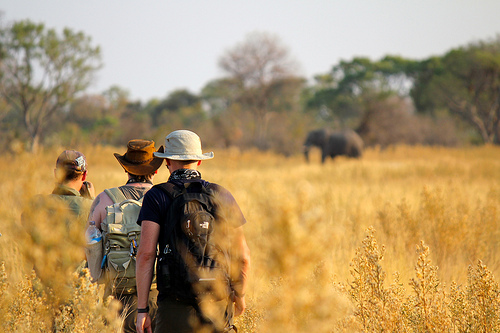Are there any giraffes in the grass that looks yellow and gold? No, there are no giraffes in the yellow and gold grass. 